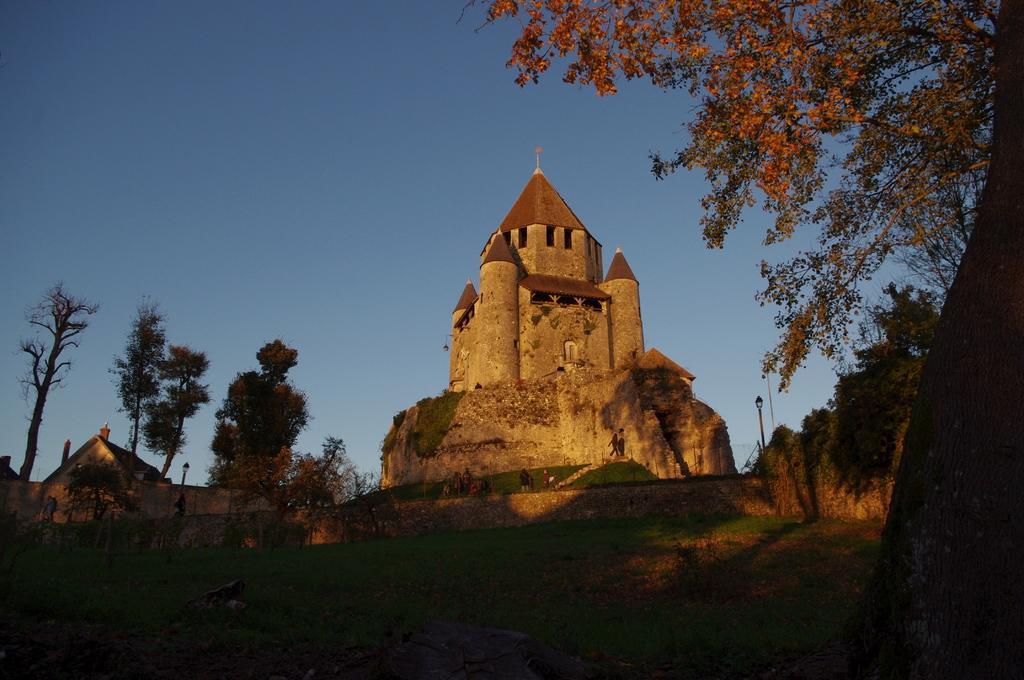In one or two sentences, can you explain what this image depicts? In the image there is a castle in the back with trees on either of it and building on the left side and above its sky. 